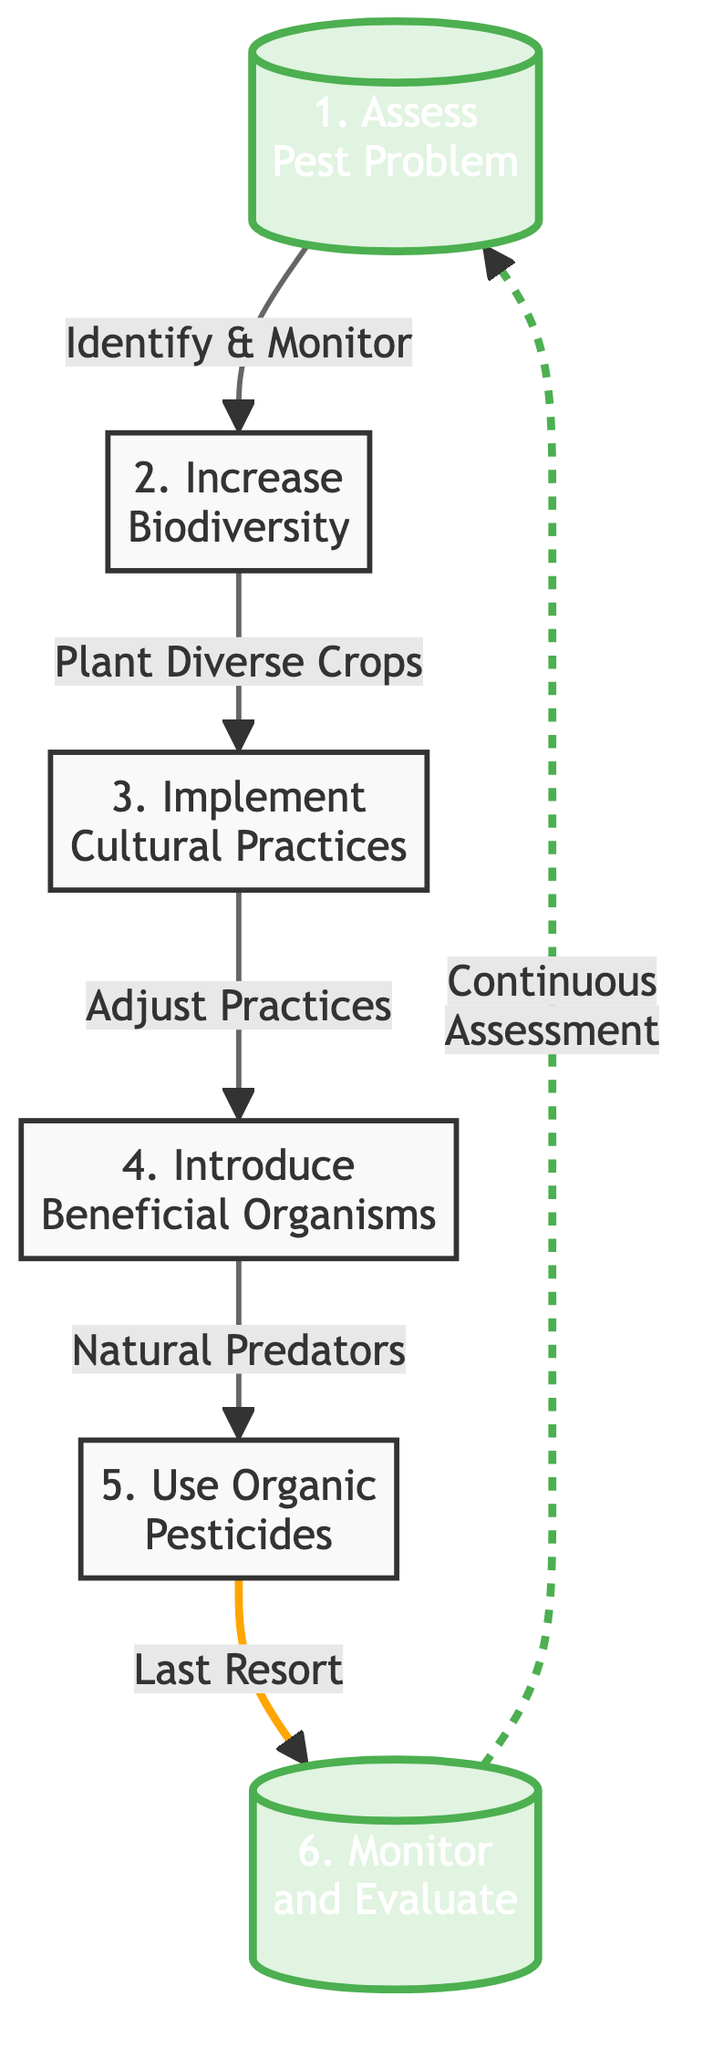What is the first step in establishing an organic pest management system? The diagram indicates that the first step is "Assess Pest Problem," which is positioned as the starting node in the flow chart before any other steps.
Answer: Assess Pest Problem How many steps are there in total? By counting the numbered steps listed in the diagram, there are a total of six distinct steps included in the process.
Answer: 6 What is the last step according to the chart? The last step in the flow chart is "Monitor and Evaluate,” which is highlighted as the endpoint of the process.
Answer: Monitor and Evaluate Which step follows "Increase Biodiversity"? The diagram shows that "Implement Cultural Practices" is positioned directly after "Increase Biodiversity," indicating it is the next logical step in the sequence.
Answer: Implement Cultural Practices What does the arrow from "Use Organic Pesticides" lead to? In the diagram, the arrow from "Use Organic Pesticides" leads to “Monitor and Evaluate,” signifying that this step naturally follows the use of pesticides.
Answer: Monitor and Evaluate What type of connection is between "Monitor and Evaluate" and "Assess Pest Problem"? The connection between "Monitor and Evaluate" and "Assess Pest Problem" is represented as a dashed line, which indicates that it is a continuous assessment loop back to the initial step for ongoing evaluation.
Answer: Continuous assessment What cultural practice is suggested in the steps? The step titled "Implement Cultural Practices" implies various methods such as crop rotation and managing irrigation, thus suggesting these practices are cultural.
Answer: Crop rotation Which beneficial organisms are mentioned in the chart? The diagram explicitly states "Introduce Beneficial Organisms," particularly referring to natural predators or parasites, like ladybugs or nematodes.
Answer: Ladybugs or nematodes What is the condition for using organic pesticides as per the chart? The chart states that organic pesticides should be "last resort," implying that they are not the first line of defense in pest management.
Answer: Last resort 